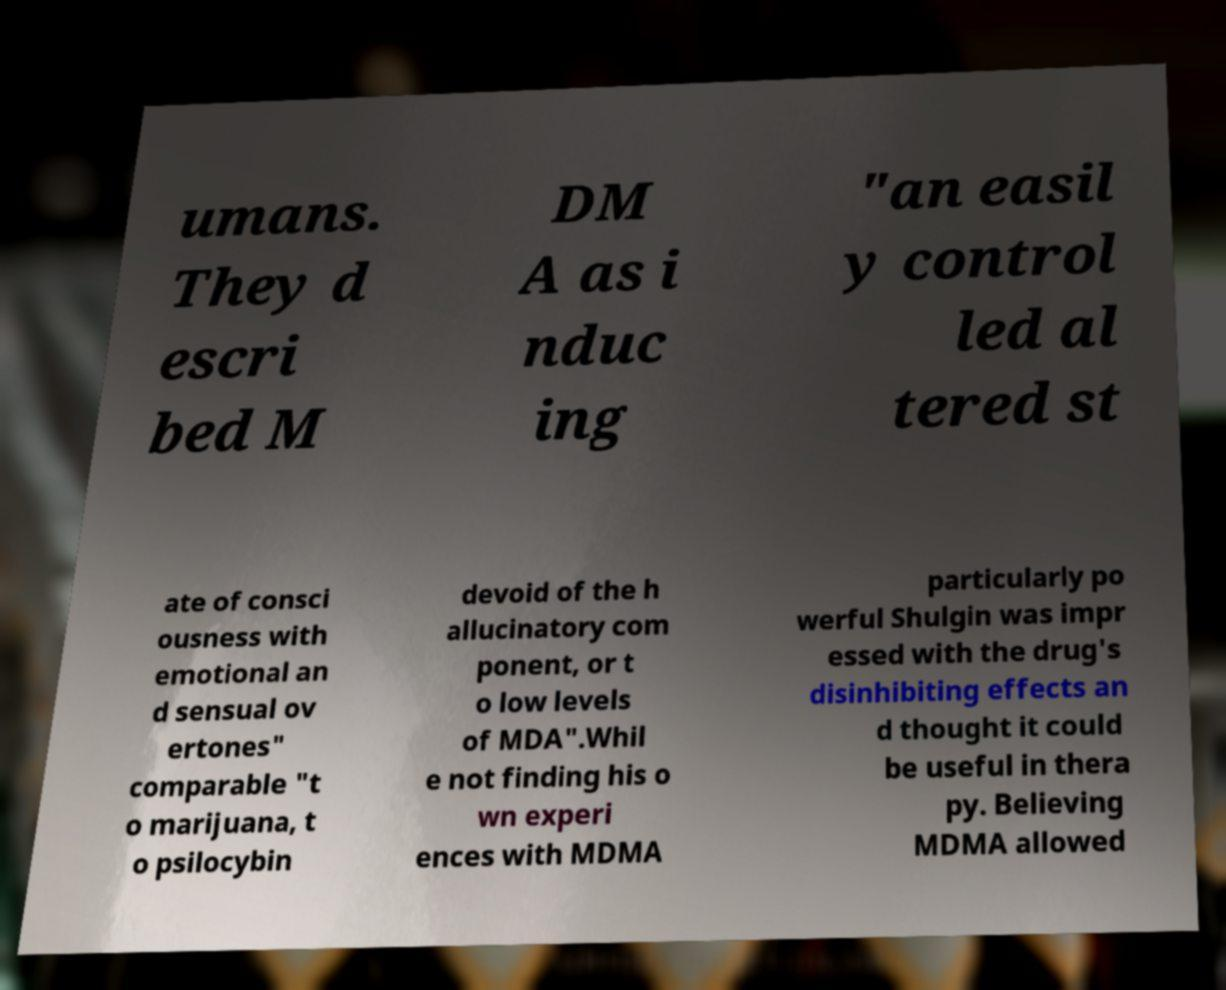Please read and relay the text visible in this image. What does it say? umans. They d escri bed M DM A as i nduc ing "an easil y control led al tered st ate of consci ousness with emotional an d sensual ov ertones" comparable "t o marijuana, t o psilocybin devoid of the h allucinatory com ponent, or t o low levels of MDA".Whil e not finding his o wn experi ences with MDMA particularly po werful Shulgin was impr essed with the drug's disinhibiting effects an d thought it could be useful in thera py. Believing MDMA allowed 